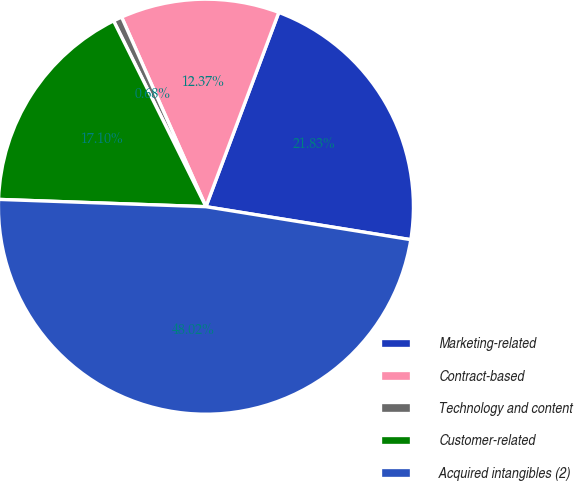Convert chart. <chart><loc_0><loc_0><loc_500><loc_500><pie_chart><fcel>Marketing-related<fcel>Contract-based<fcel>Technology and content<fcel>Customer-related<fcel>Acquired intangibles (2)<nl><fcel>21.83%<fcel>12.37%<fcel>0.68%<fcel>17.1%<fcel>48.02%<nl></chart> 